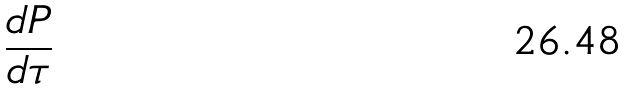Convert formula to latex. <formula><loc_0><loc_0><loc_500><loc_500>\frac { d P } { d \tau }</formula> 